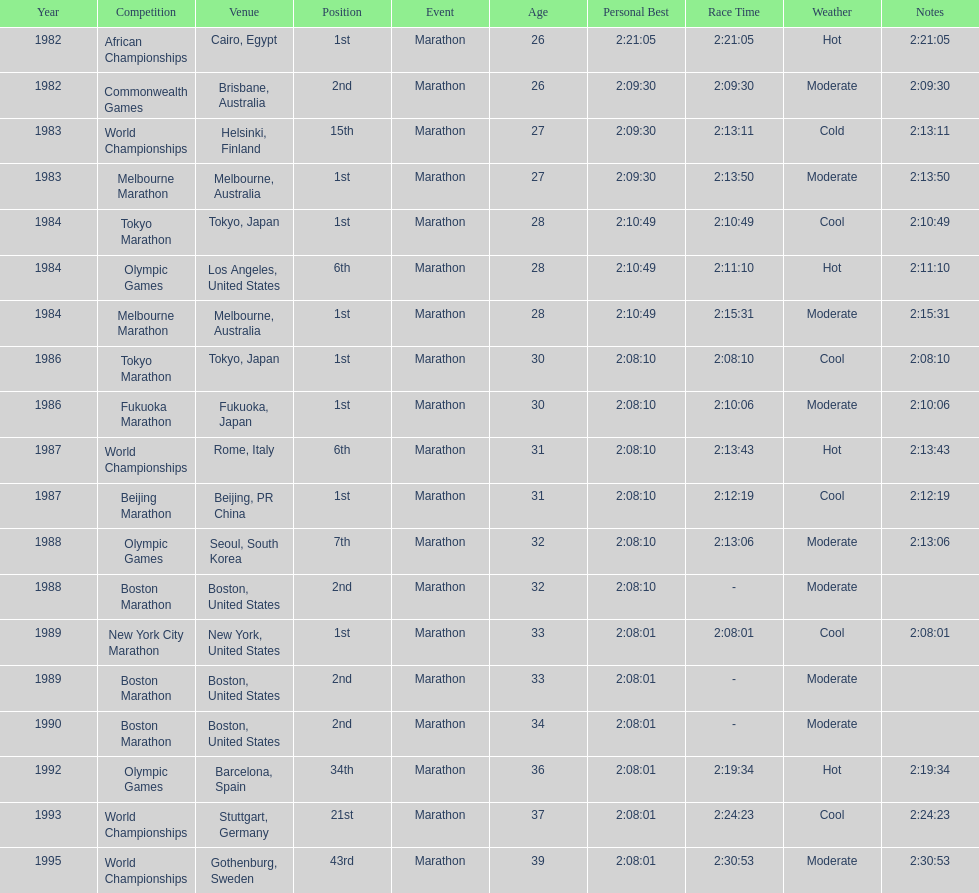How many times in total did ikangaa run the marathon in the olympic games? 3. 